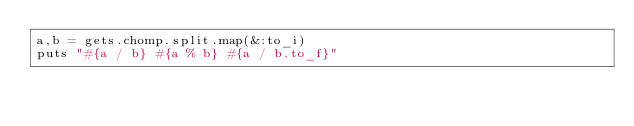<code> <loc_0><loc_0><loc_500><loc_500><_Ruby_>a,b = gets.chomp.split.map(&:to_i)
puts "#{a / b} #{a % b} #{a / b.to_f}"</code> 